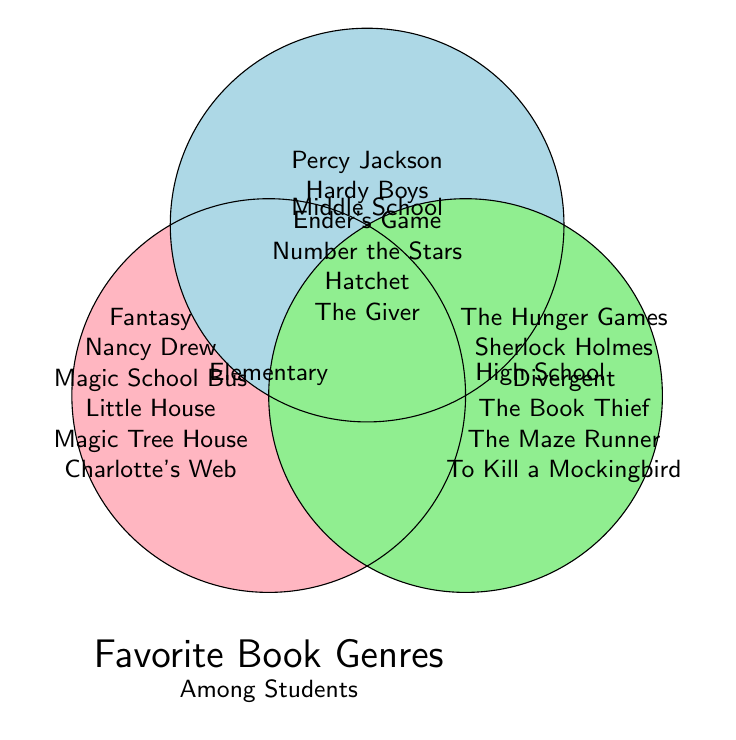Which school level prefers "Harry Potter"? To find this information, look at the section of the Venn Diagram labelled "Fantasy" under the "Elementary" circle.
Answer: Elementary Which genre is shared between Middle School and High School but not Elementary? Examine the overlapping area between Middle School and High School circles but outside of the Elementary circle. The genre listed here is "Science Fiction".
Answer: Science Fiction What are the genres exclusively popular in High School? Look into the part of the "High School" circle that doesn't overlap with the other circles, identifying the genres listed there.
Answer: Mystery, Science Fiction, Fantasy, Adventure, Classics Which genres are popular in Elementary but not in Middle School? Check the part of the "Elementary" circle that doesn't overlap with the "Middle School" circle but might overlap with "High School". List those genres.
Answer: Fantasy, Mystery, Science Fiction, Historical Fiction, Adventure, Classics How many distinct genres are popular across all three school levels? Identify the genres that appear in the intersection of all three circles. Here, there are no genres listed in the intersection area.
Answer: 0 